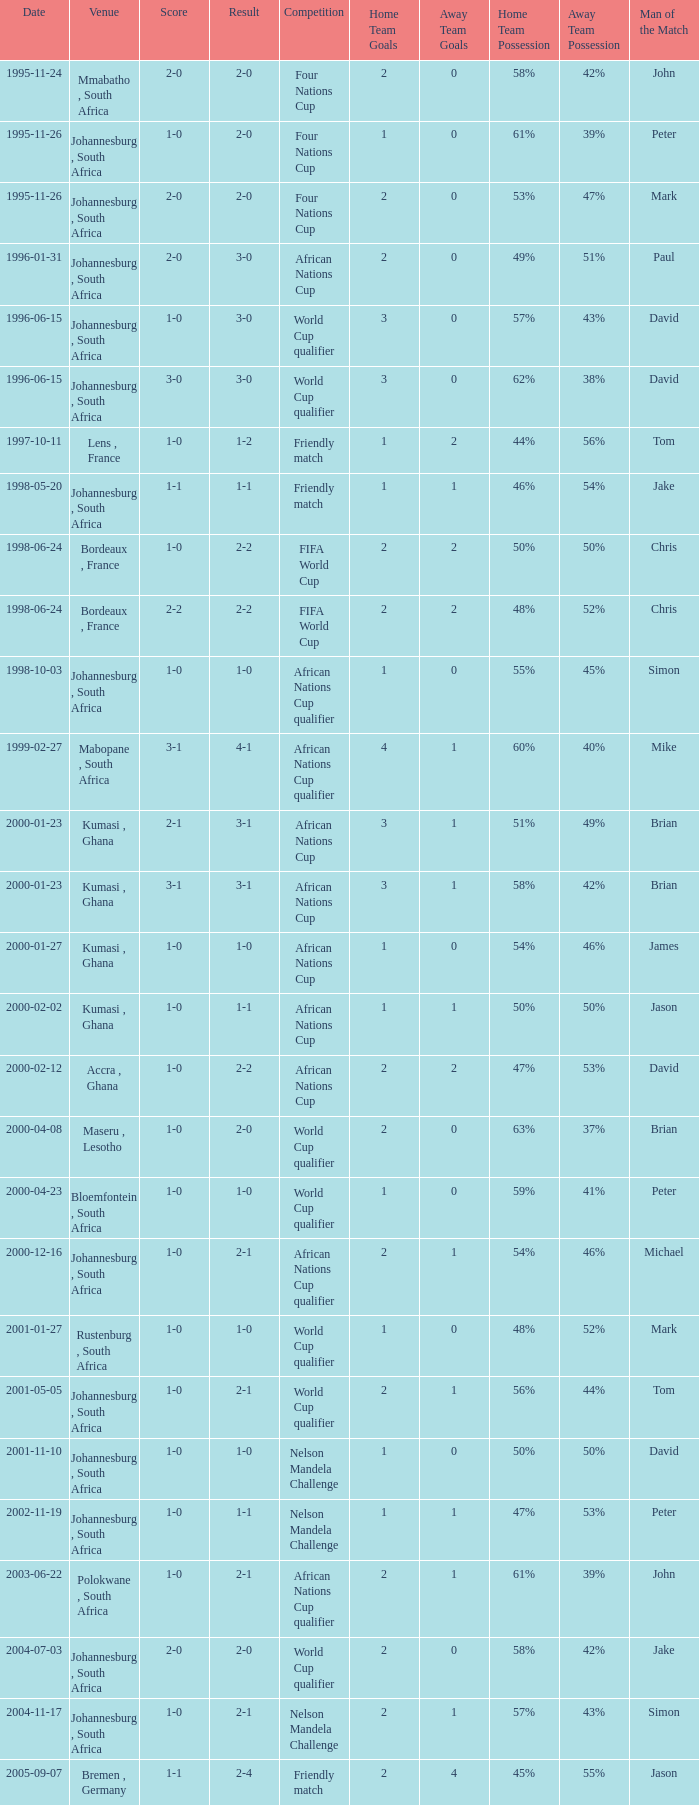What is the Date of the Fifa World Cup with a Score of 1-0? 1998-06-24. 